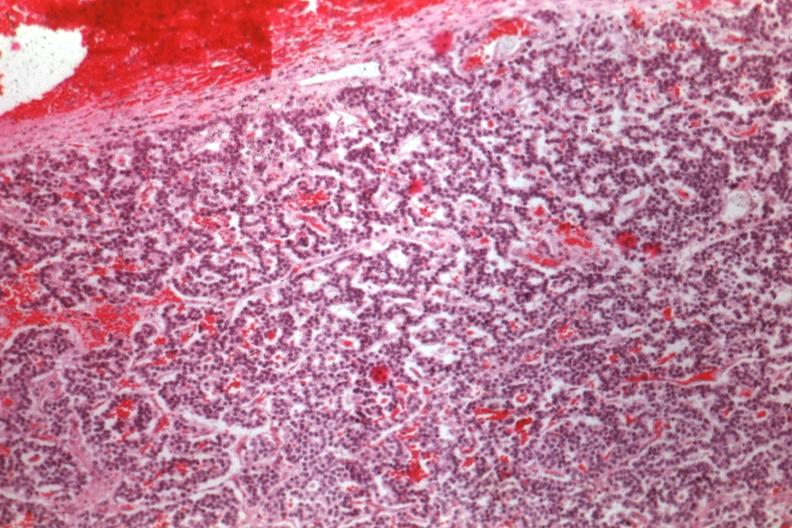what is present?
Answer the question using a single word or phrase. Endocrine 